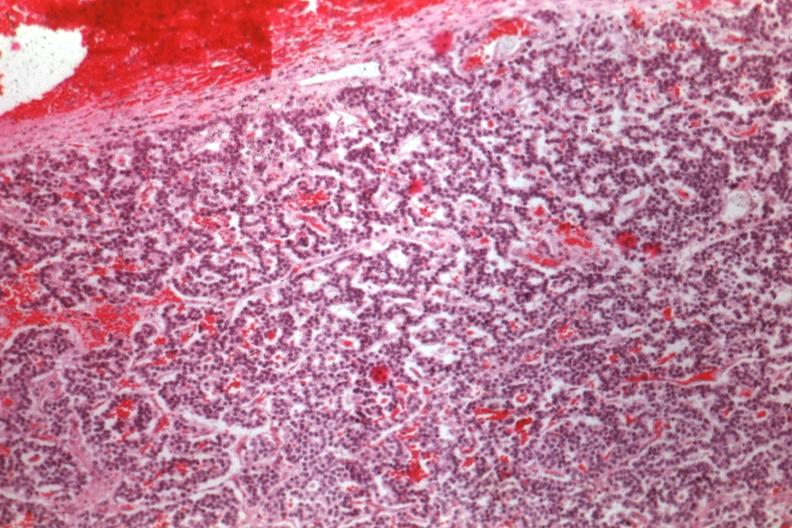what is present?
Answer the question using a single word or phrase. Endocrine 